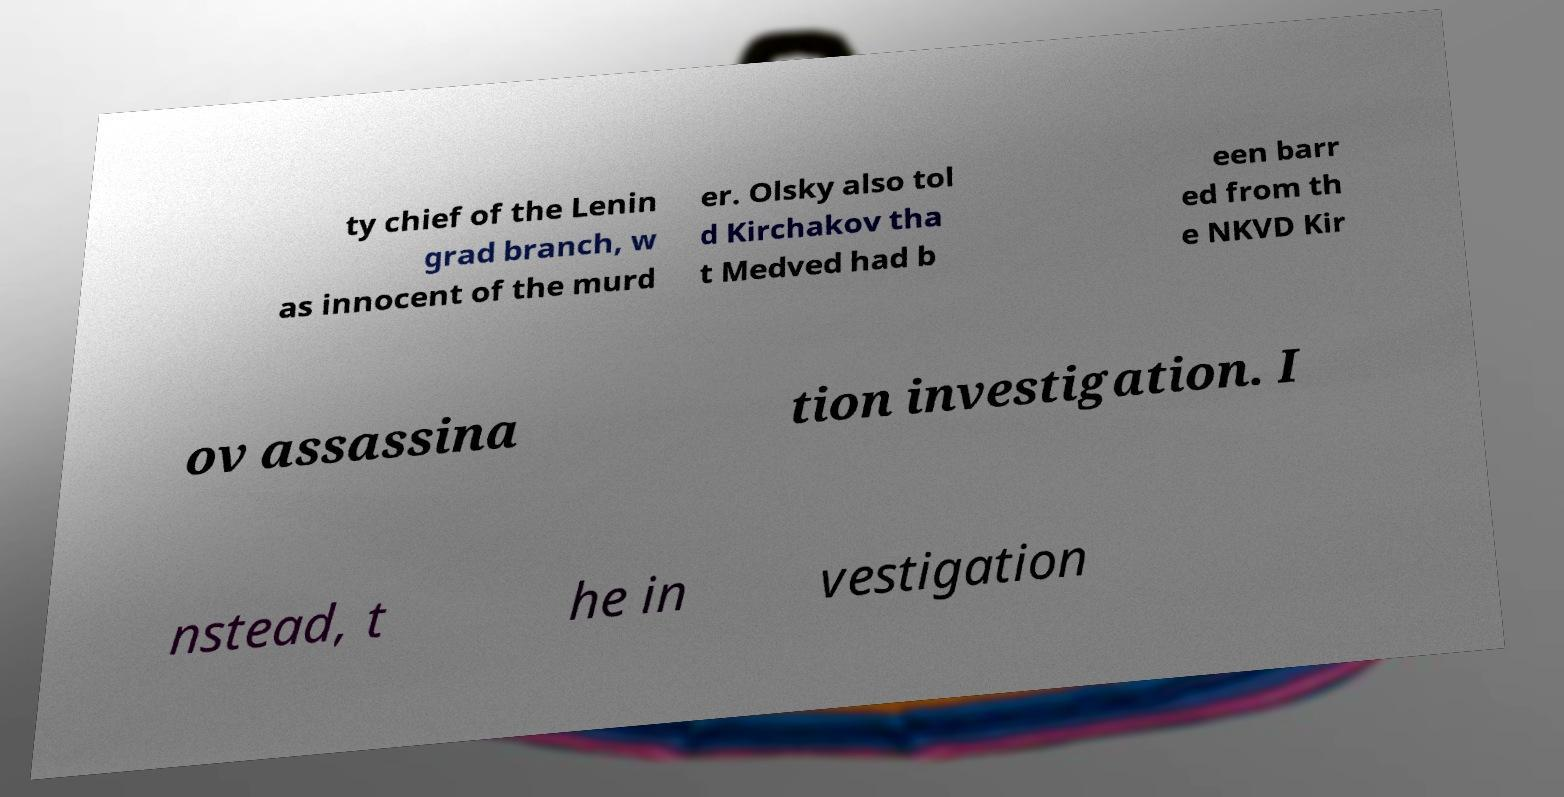Please identify and transcribe the text found in this image. ty chief of the Lenin grad branch, w as innocent of the murd er. Olsky also tol d Kirchakov tha t Medved had b een barr ed from th e NKVD Kir ov assassina tion investigation. I nstead, t he in vestigation 